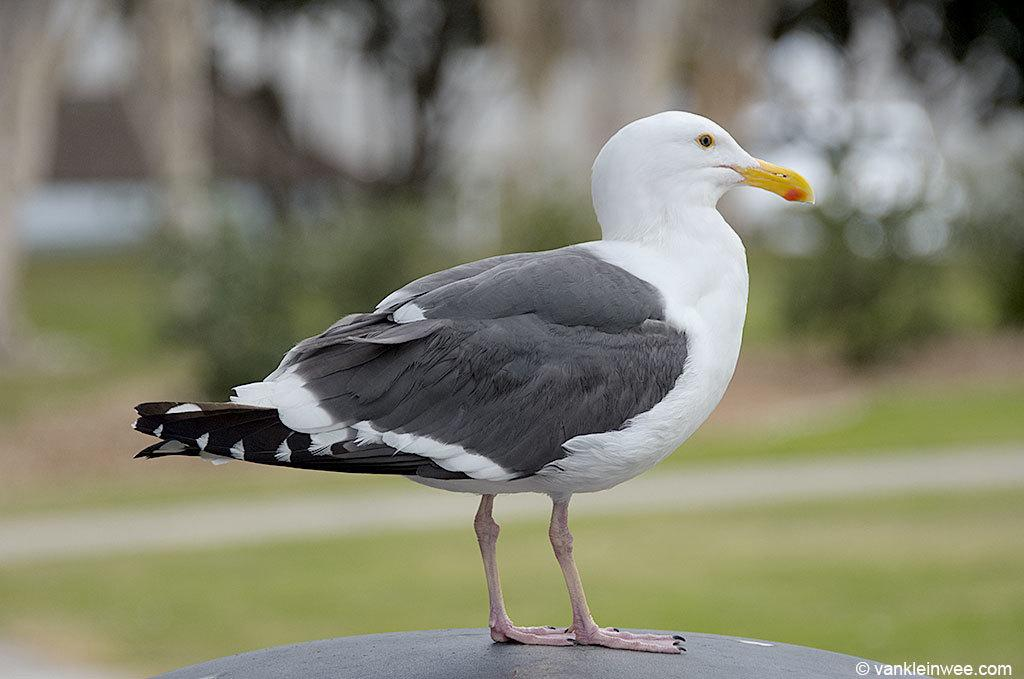What is the main subject of the image? There is a bird in the middle of the image. Can you describe the bird's appearance? The bird is in white and black color. How would you describe the background of the image? The background of the image is blurred. What type of guitar is the bird playing in the image? There is no guitar present in the image; it features a bird in white and black color with a blurred background. 